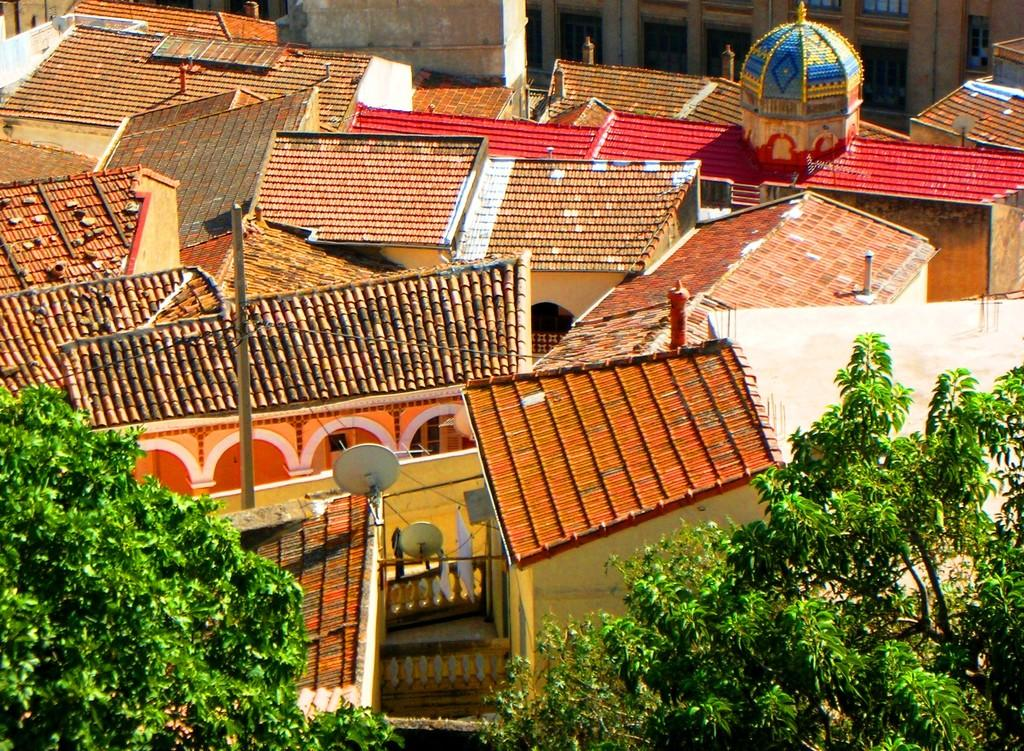What type of structures are visible in the image? The image contains the roofs of houses. What type of natural elements can be seen in the image? There are trees visible in the image. What additional features can be seen on the houses in the image? There are antennas in the image. Where is the school located in the image? There is no school present in the image. What type of flower can be seen growing near the trees in the image? There are no flowers visible in the image. 